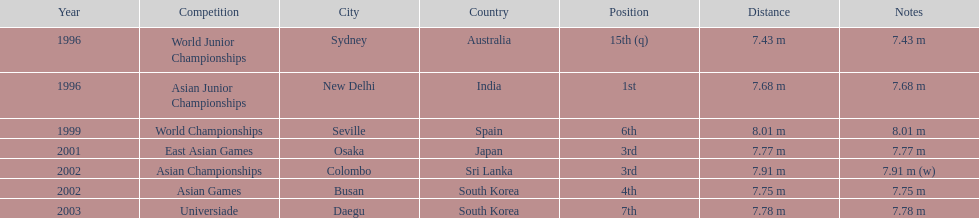How long was huang le's longest jump in 2002? 7.91 m (w). 